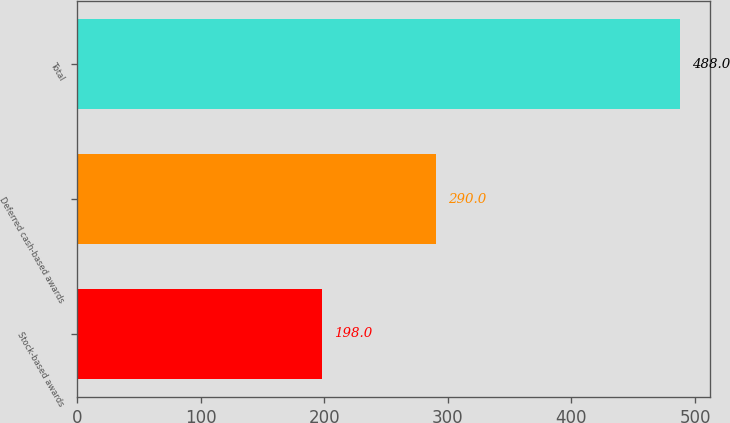<chart> <loc_0><loc_0><loc_500><loc_500><bar_chart><fcel>Stock-based awards<fcel>Deferred cash-based awards<fcel>Total<nl><fcel>198<fcel>290<fcel>488<nl></chart> 